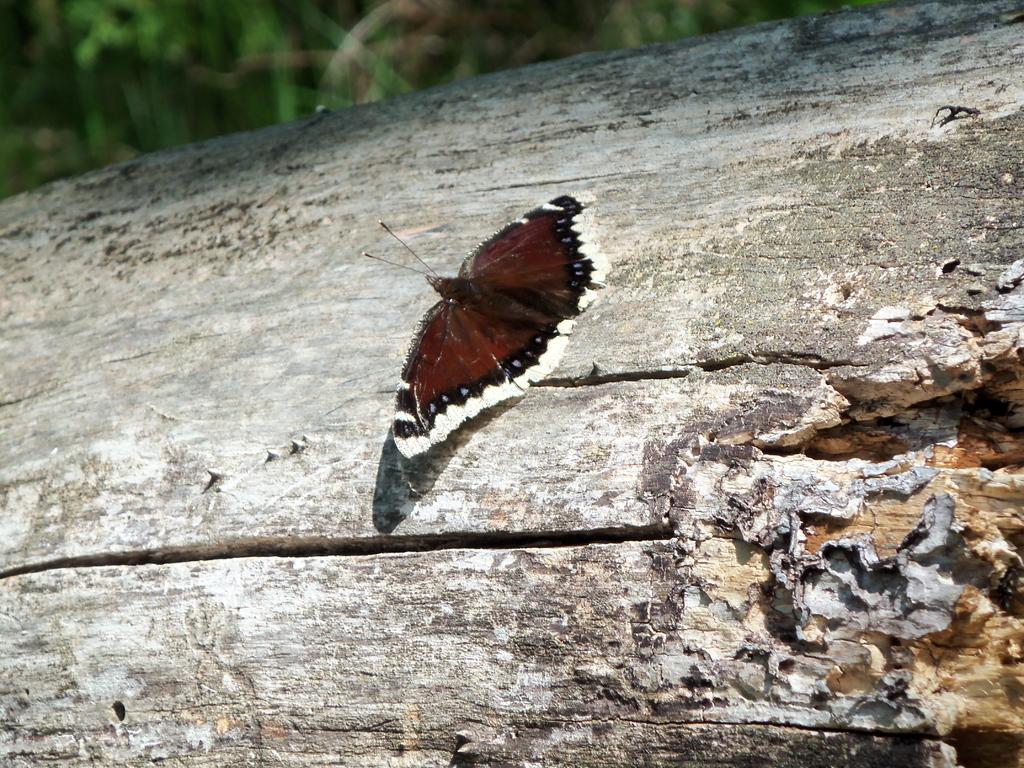How would you summarize this image in a sentence or two? In the picture there is a butterfly laying on a wood, it is of brown color. 